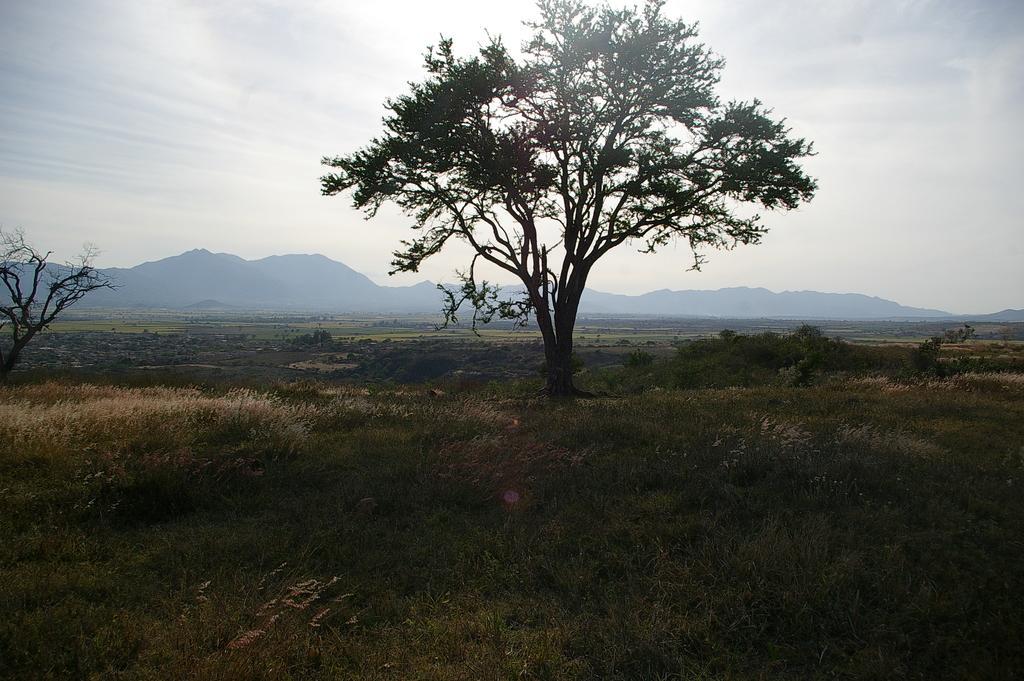Could you give a brief overview of what you see in this image? In the picture I can see trees, plants and the grass. In the background I can see mountains and the sky. 